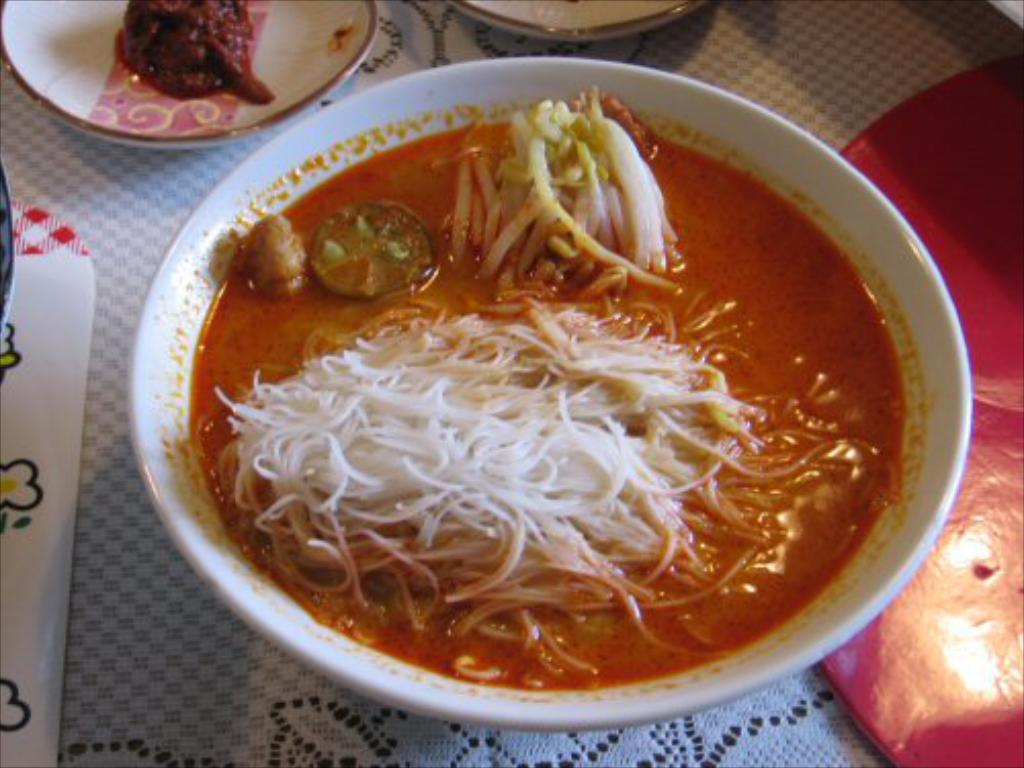Describe this image in one or two sentences. In this image I can see a table which is covered with a cloth. On the table there are some bowls which consists of different food items. On the right side there is a red color object is placed on the table. 